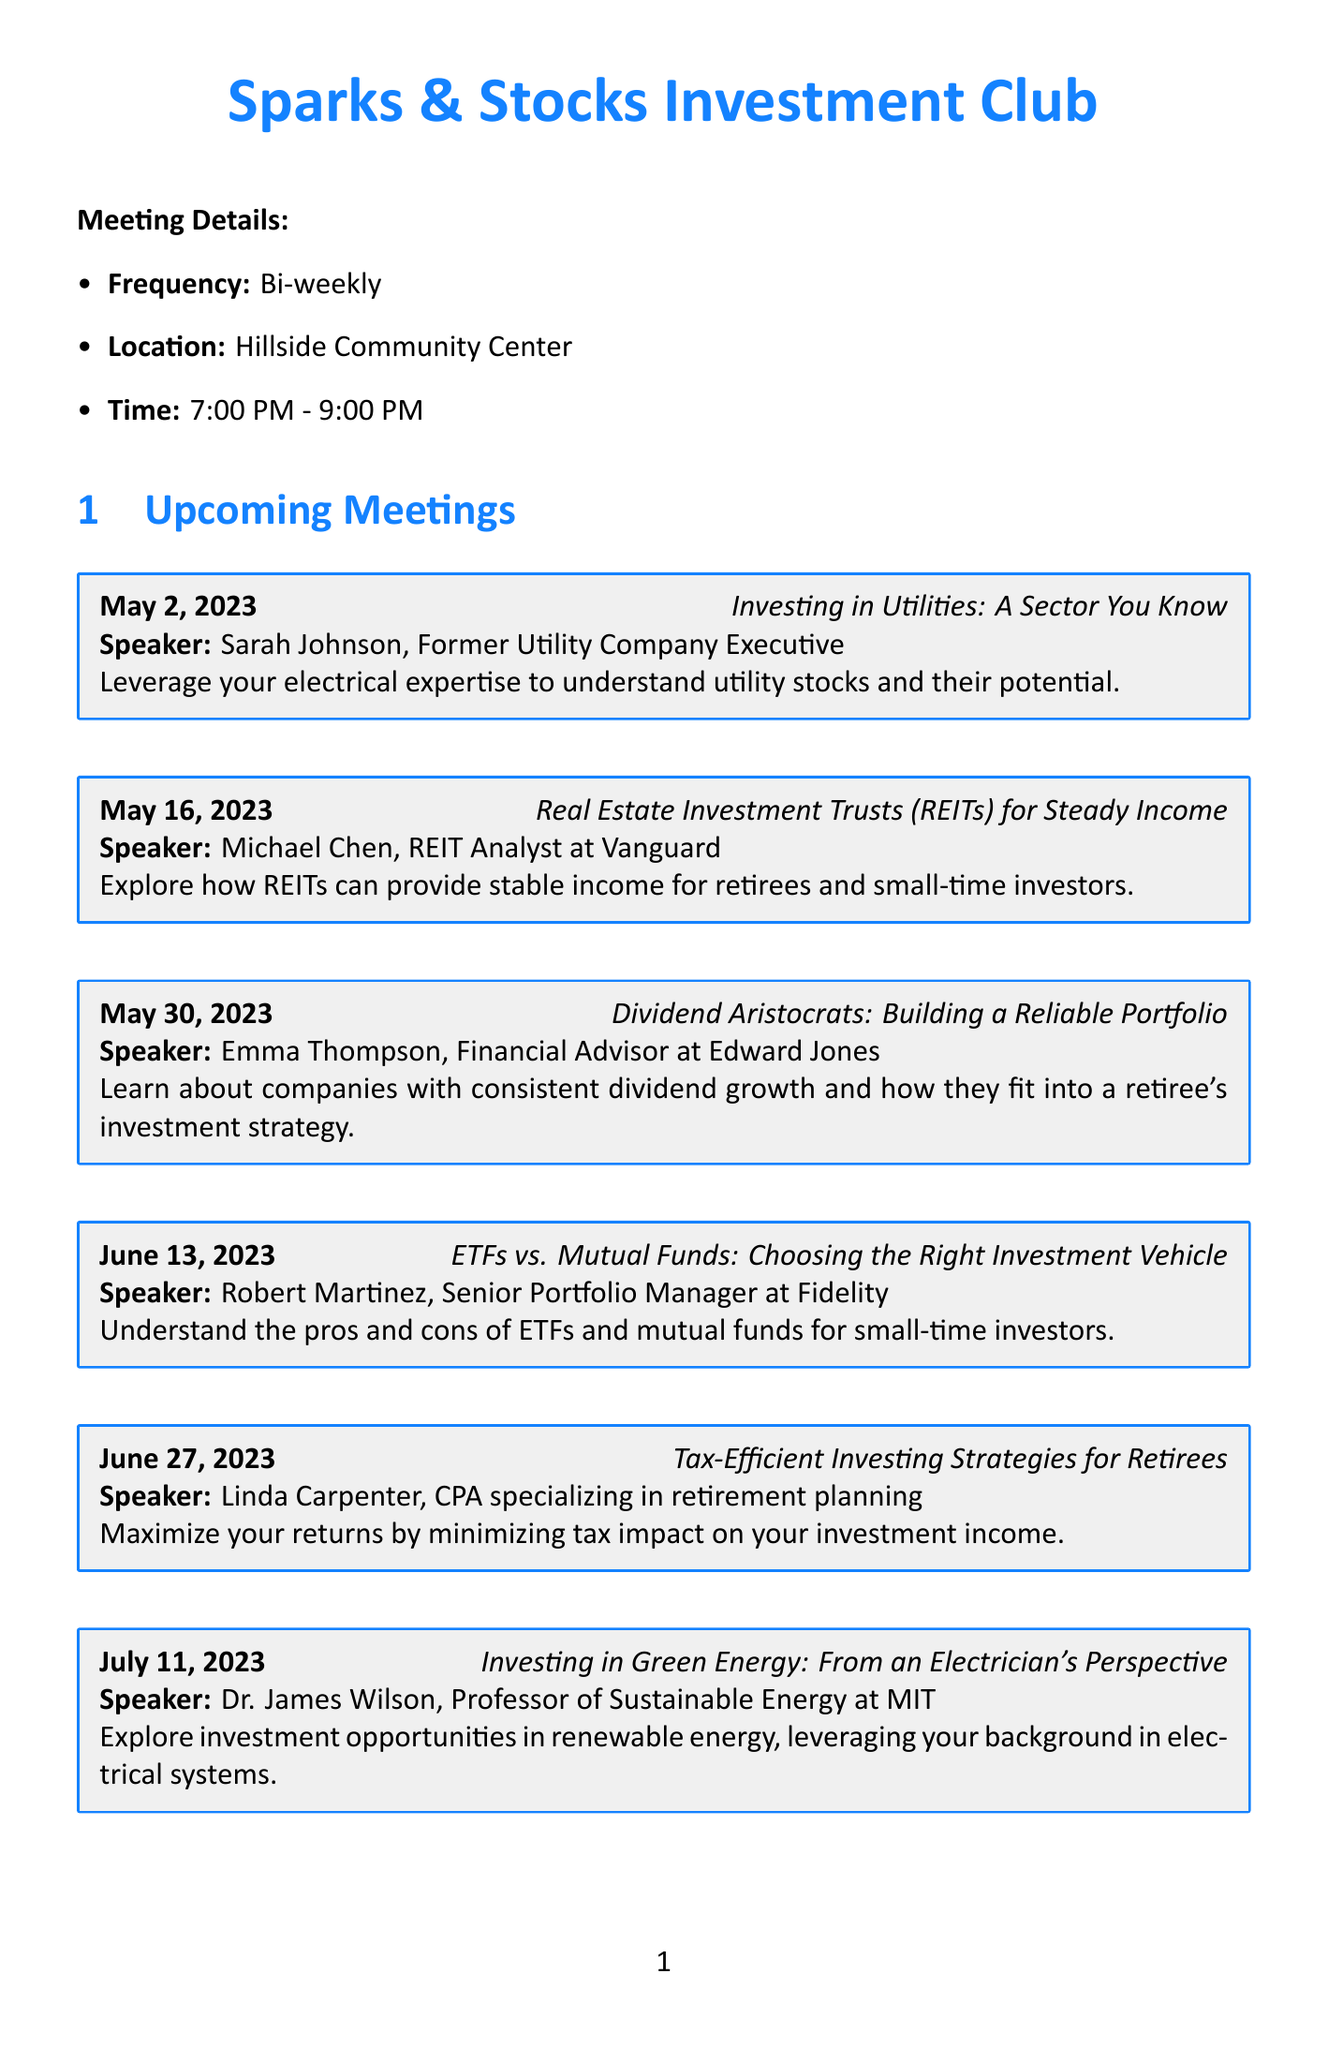What is the name of the investment club? The document specifies the name of the club as "Sparks & Stocks Investment Club."
Answer: Sparks & Stocks Investment Club When do the meetings take place? The document states that meetings are held bi-weekly, specifically on Tuesdays.
Answer: Bi-weekly Who is the speaker for the May 16 meeting? According to the document, the speaker for the May 16 meeting is Michael Chen.
Answer: Michael Chen How long is each guest speaker's presentation? The document indicates that each guest speaker has a 45-minute presentation followed by a Q&A session.
Answer: 45 minutes What is the annual membership fee? The document mentions that the annual membership fee is $50.
Answer: $50 What is the topic for the meeting on July 11? The document lists the topic for the July 11 meeting as "Investing in Green Energy: From an Electrician's Perspective."
Answer: Investing in Green Energy: From an Electrician's Perspective How many meetings must members attend to meet the requirement? The document specifies that members are expected to attend at least 75% of the meetings.
Answer: 75% What resource is provided for investment education? The document lists several resources, one of which is Investopedia for investment education.
Answer: Investopedia 